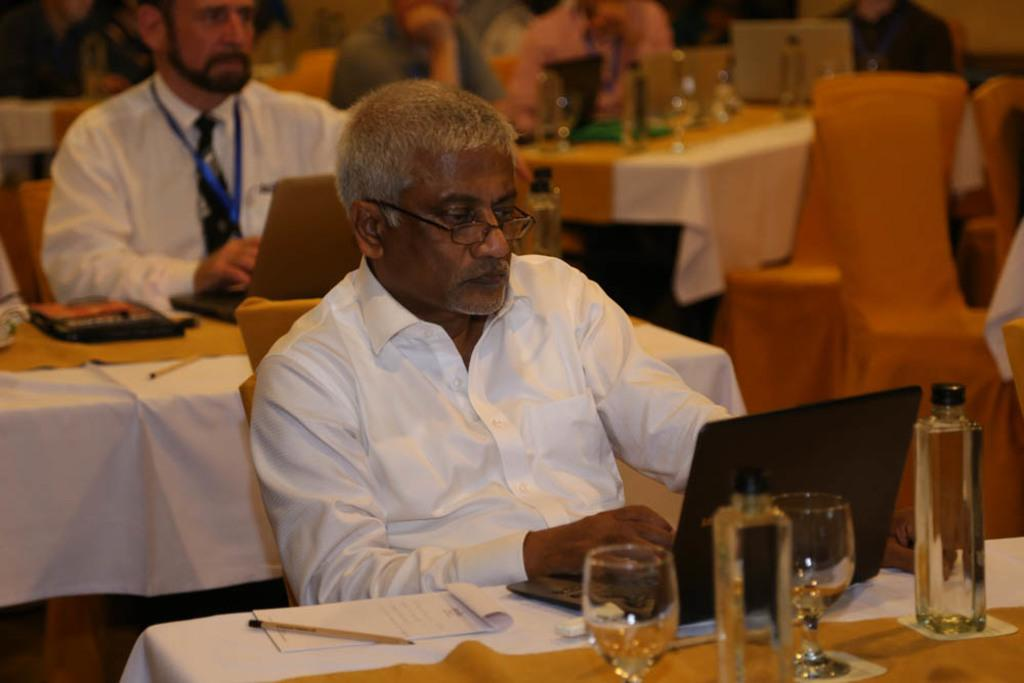Who is the main subject in the image? There is a man in the image. What is the man looking at? The man is looking at a chair and a laptop. What other objects can be seen in the image? There is a wine glass, bottles, and a book in the image. Are there any other people in the image? Yes, there is another man behind the first man. What title is the man holding in the image? There is no title visible in the image. What reward is the man receiving for his work in the image? There is no indication of a reward or work in the image. 